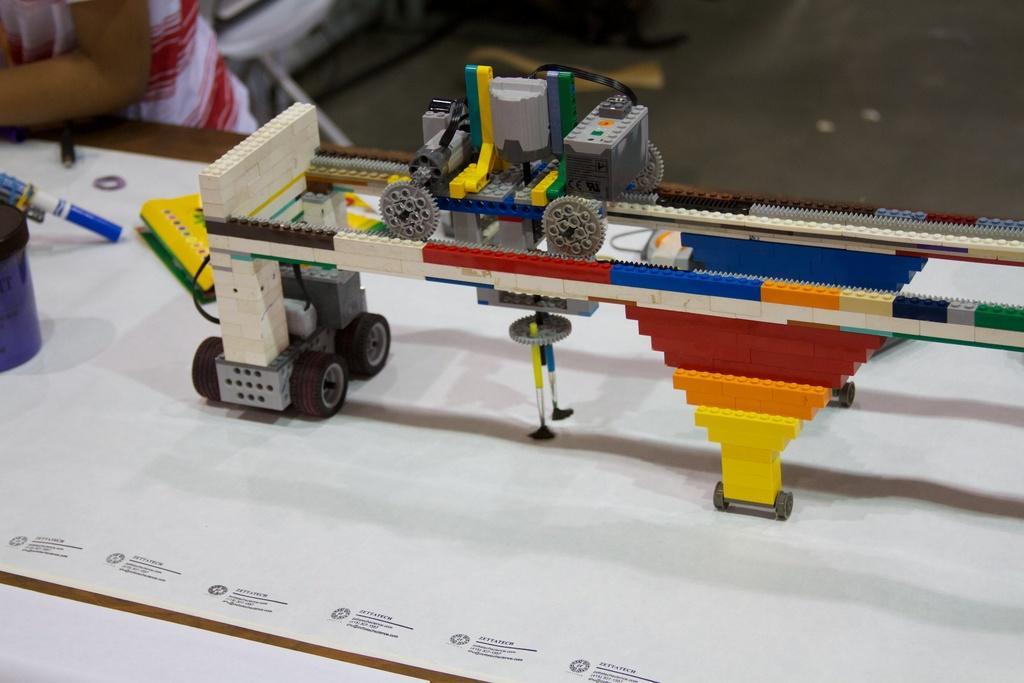In one or two sentences, can you explain what this image depicts? This image consists of a miniature. Two vehicles are made with the miniature blocks. On the left, we can see a person standing. At the bottom, there is a table. In the background, we can see a floor. 